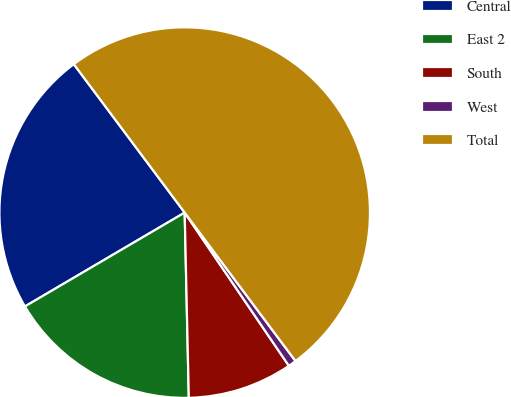Convert chart. <chart><loc_0><loc_0><loc_500><loc_500><pie_chart><fcel>Central<fcel>East 2<fcel>South<fcel>West<fcel>Total<nl><fcel>23.24%<fcel>16.9%<fcel>9.15%<fcel>0.7%<fcel>50.0%<nl></chart> 